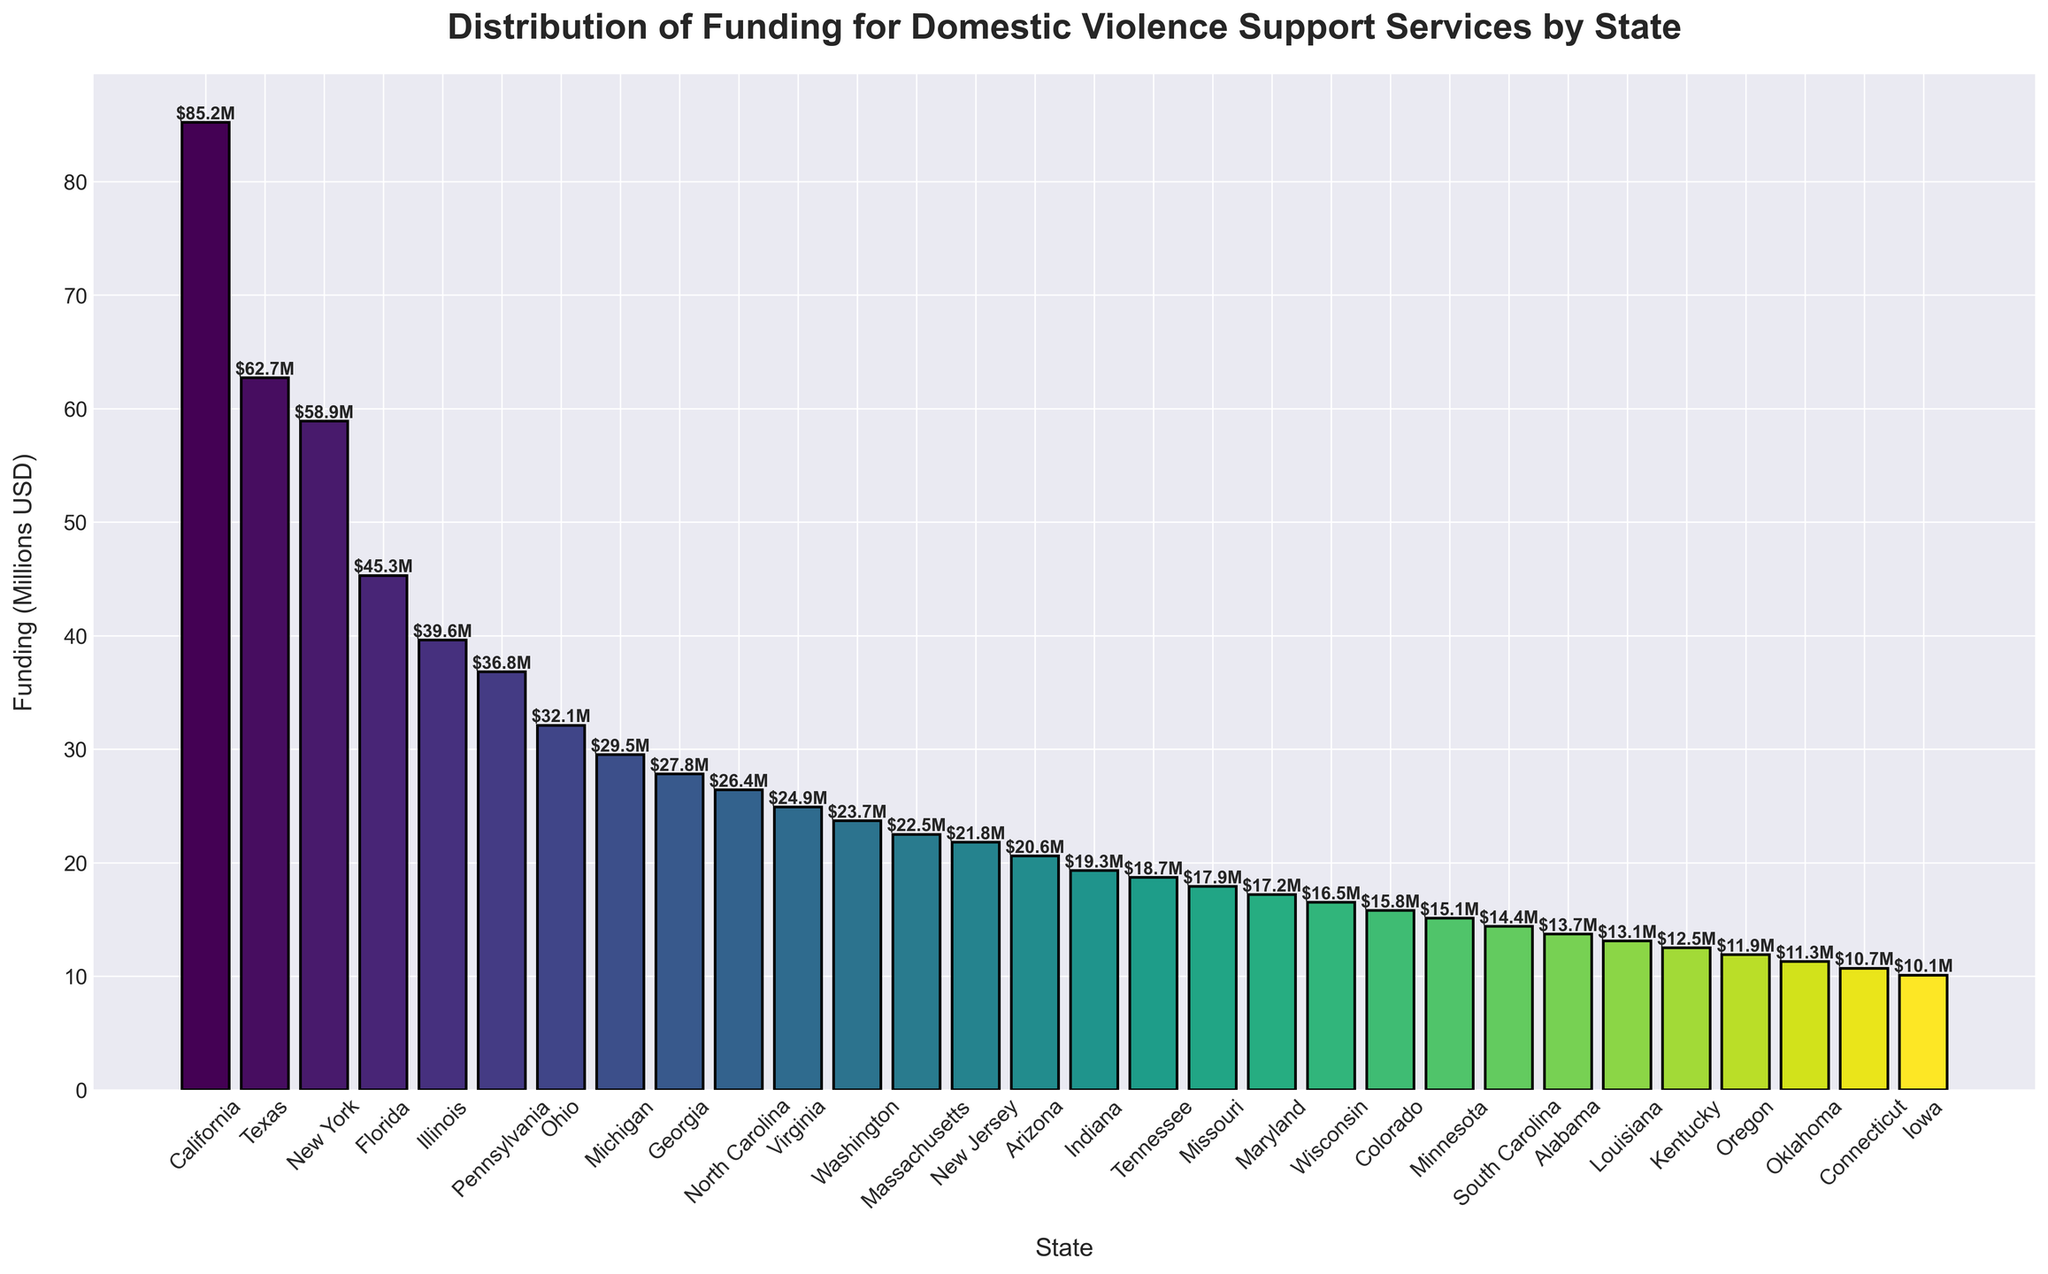Which state received the highest funding for domestic violence support services? The state with the tallest bar represents the highest funding. According to the figure, California has the tallest bar.
Answer: California What is the total funding for the top three states combined? Identify the funding amounts for California ($85.2M), Texas ($62.7M), and New York ($58.9M). Sum these values: $85.2M + $62.7M + $58.9M = $206.8M
Answer: $206.8M How does the funding for Florida compare to Illinois? Look at the heights of the bars for Florida and Illinois. Florida has a bar height of $45.3M, while Illinois has a bar height of $39.6M, making Florida's funding higher.
Answer: Florida has higher funding than Illinois Which state received the lowest funding? The state with the shortest bar represents the lowest funding. According to the figure, Iowa has the shortest bar.
Answer: Iowa What is the average funding of the states listed in the figure? Sum the funding amounts for all the states and divide by the number of states. Total funding is the sum of all bar heights, which is $677.3M. Divide by 30 states: $677.3M / 30 ≈ $22.6M.
Answer: $22.6M Are there any states that received equal or nearly equal funding? Look at the heights of the bars to check for bars of equal or nearly equal height. New York ($58.9M) and Illinois ($39.6M) do not have bars of equal height. However, Minnesota ($15.1M) and Wisconsin ($16.5M) have nearly equal heights.
Answer: Minnesota and Wisconsin How much more funding did Ohio receive than Kentucky? Subtract Kentucky's funding from Ohio's funding: $32.1M - $12.5M = $19.6M.
Answer: $19.6M What proportion of the total funding is allocated to California? Divide California's funding by the total funding of all states and multiply by 100 to get the percentage: ($85.2M / $677.3M) * 100 ≈ 12.6%.
Answer: 12.6% Which regions are represented by the states receiving the three highest fundings? Identify the states with the three highest fundings: California (West), Texas (South), New York (Northeast).
Answer: West, South, Northeast How does the funding distribution compare visually between the top and bottom five states? Observe the heights and colors of the bars for the top five (California, Texas, New York, Florida, Illinois) and bottom five (Louisiana, Kentucky, Oregon, Oklahoma, Connecticut). The top five states have significantly taller and often darker-colored bars, indicating higher funding, while the bottom five have shorter and lighter-colored bars.
Answer: Top five states have higher funding than bottom five states 